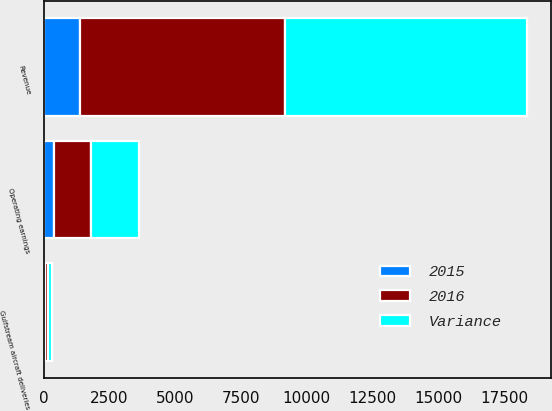Convert chart. <chart><loc_0><loc_0><loc_500><loc_500><stacked_bar_chart><ecel><fcel>Revenue<fcel>Operating earnings<fcel>Gulfstream aircraft deliveries<nl><fcel>2016<fcel>7815<fcel>1407<fcel>121<nl><fcel>Variance<fcel>9177<fcel>1807<fcel>152<nl><fcel>2015<fcel>1362<fcel>400<fcel>31<nl></chart> 